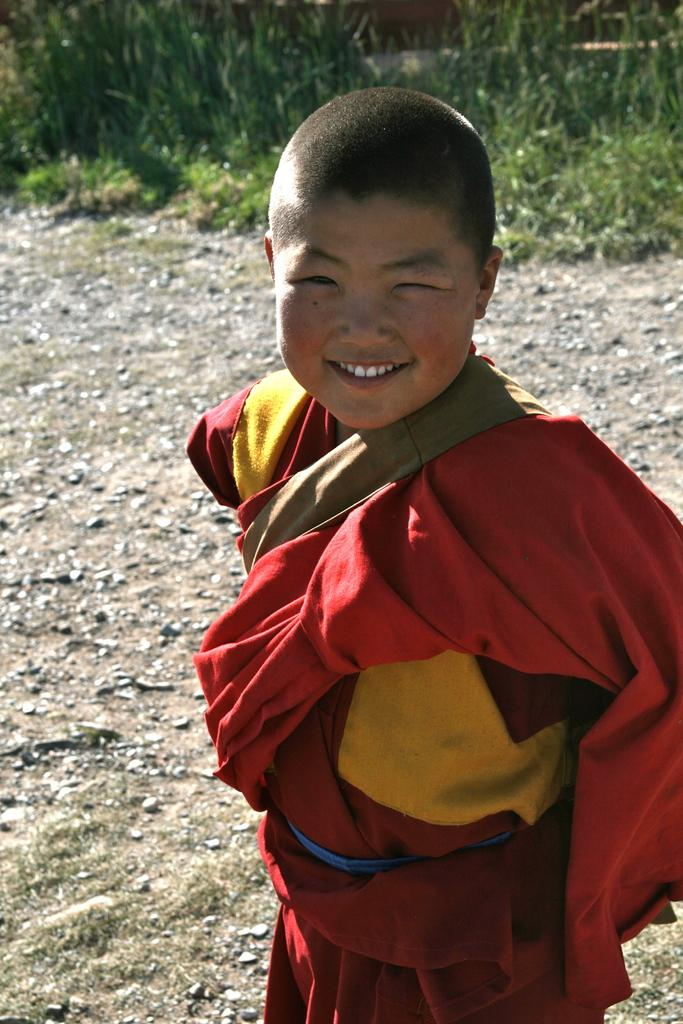What is the main subject of the image? The main subject of the image is a kid standing. What is the kid wearing in the image? The kid is wearing a red dress in the image. What can be seen in the background of the image? There are plants on the ground in the background of the image. What type of light bulb is hanging from the tree in the image? There is no light bulb present in the image; it features a kid standing and plants in the background. 